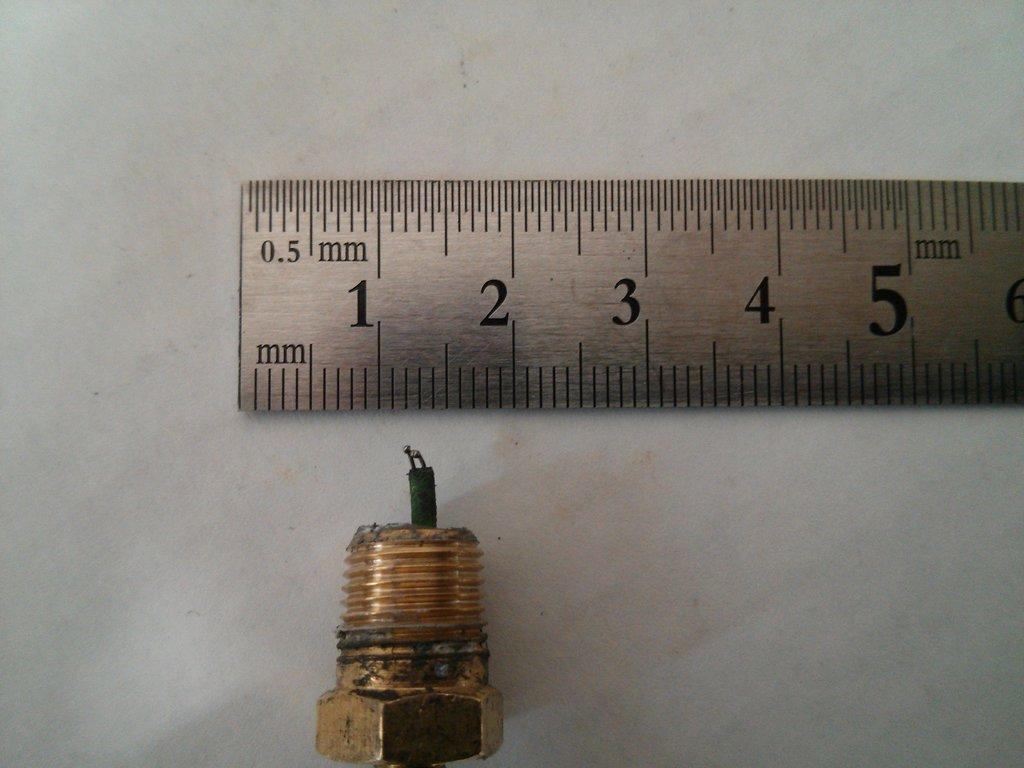<image>
Present a compact description of the photo's key features. Ruler that says 0.5mm on the top measuring a screw bolt. 